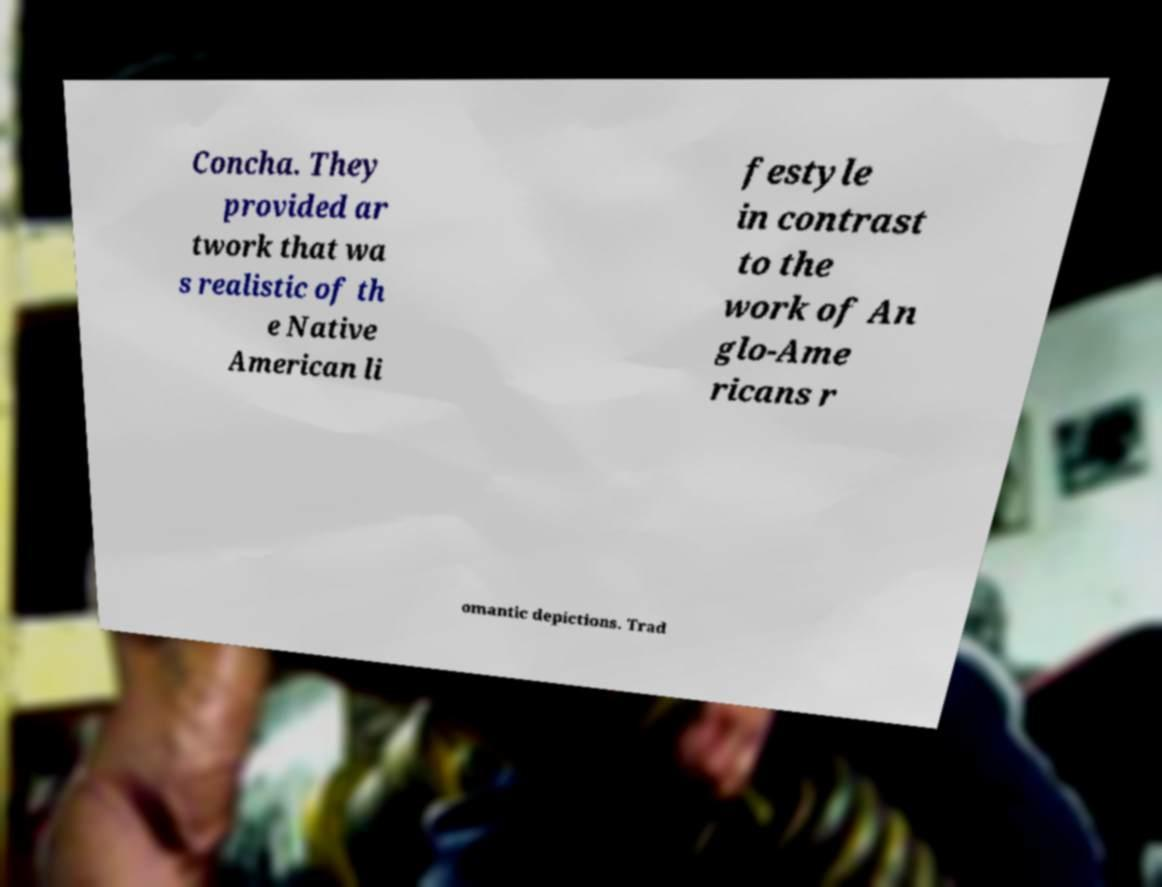I need the written content from this picture converted into text. Can you do that? Concha. They provided ar twork that wa s realistic of th e Native American li festyle in contrast to the work of An glo-Ame ricans r omantic depictions. Trad 